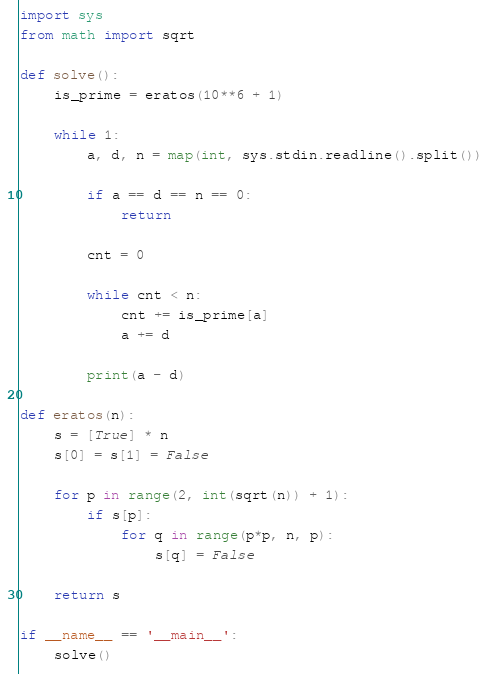Convert code to text. <code><loc_0><loc_0><loc_500><loc_500><_Python_>import sys
from math import sqrt

def solve():
    is_prime = eratos(10**6 + 1)

    while 1:
        a, d, n = map(int, sys.stdin.readline().split())

        if a == d == n == 0:
            return

        cnt = 0

        while cnt < n:
            cnt += is_prime[a]
            a += d

        print(a - d)

def eratos(n):
    s = [True] * n
    s[0] = s[1] = False

    for p in range(2, int(sqrt(n)) + 1):
        if s[p]:
            for q in range(p*p, n, p):
                s[q] = False

    return s

if __name__ == '__main__':
    solve()</code> 